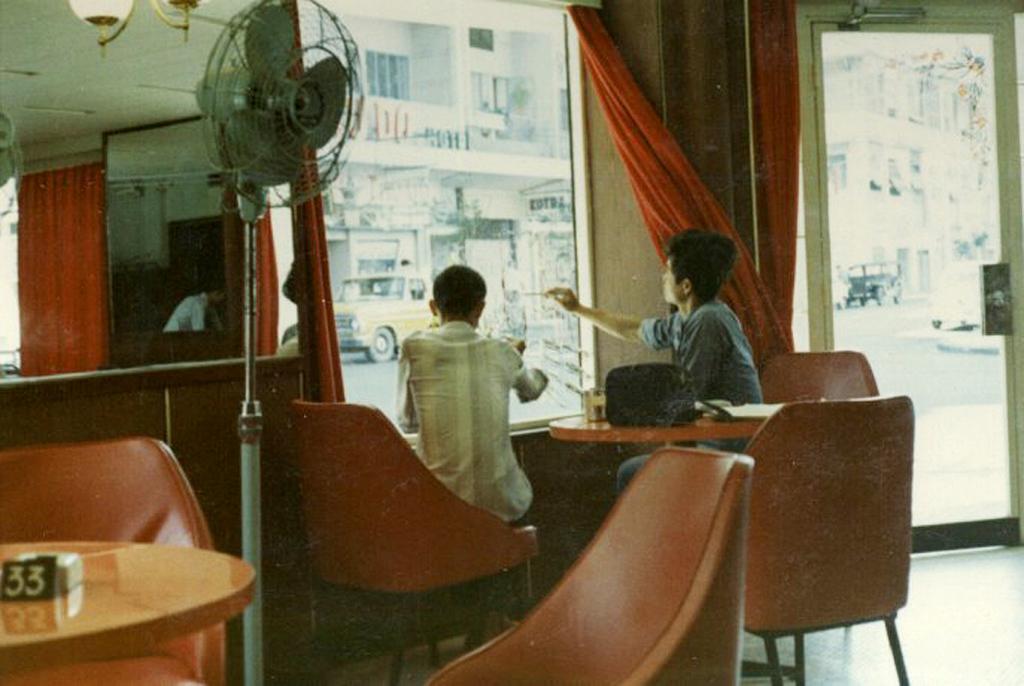Can you describe this image briefly? There are two people sitting in chair and looking at the window and there are a fan,mirror and a door besides them. 